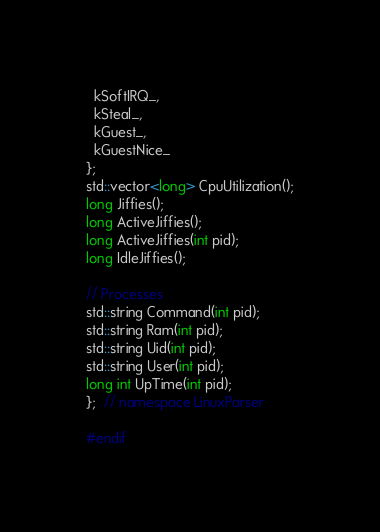<code> <loc_0><loc_0><loc_500><loc_500><_C_>  kSoftIRQ_,
  kSteal_,
  kGuest_,
  kGuestNice_
};
std::vector<long> CpuUtilization();
long Jiffies();
long ActiveJiffies();
long ActiveJiffies(int pid);
long IdleJiffies();

// Processes
std::string Command(int pid);
std::string Ram(int pid);
std::string Uid(int pid);
std::string User(int pid);
long int UpTime(int pid);
};  // namespace LinuxParser

#endif</code> 